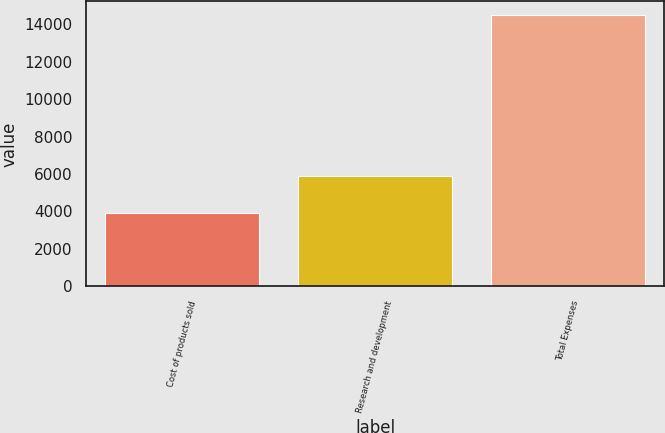Convert chart. <chart><loc_0><loc_0><loc_500><loc_500><bar_chart><fcel>Cost of products sold<fcel>Research and development<fcel>Total Expenses<nl><fcel>3909<fcel>5920<fcel>14483<nl></chart> 